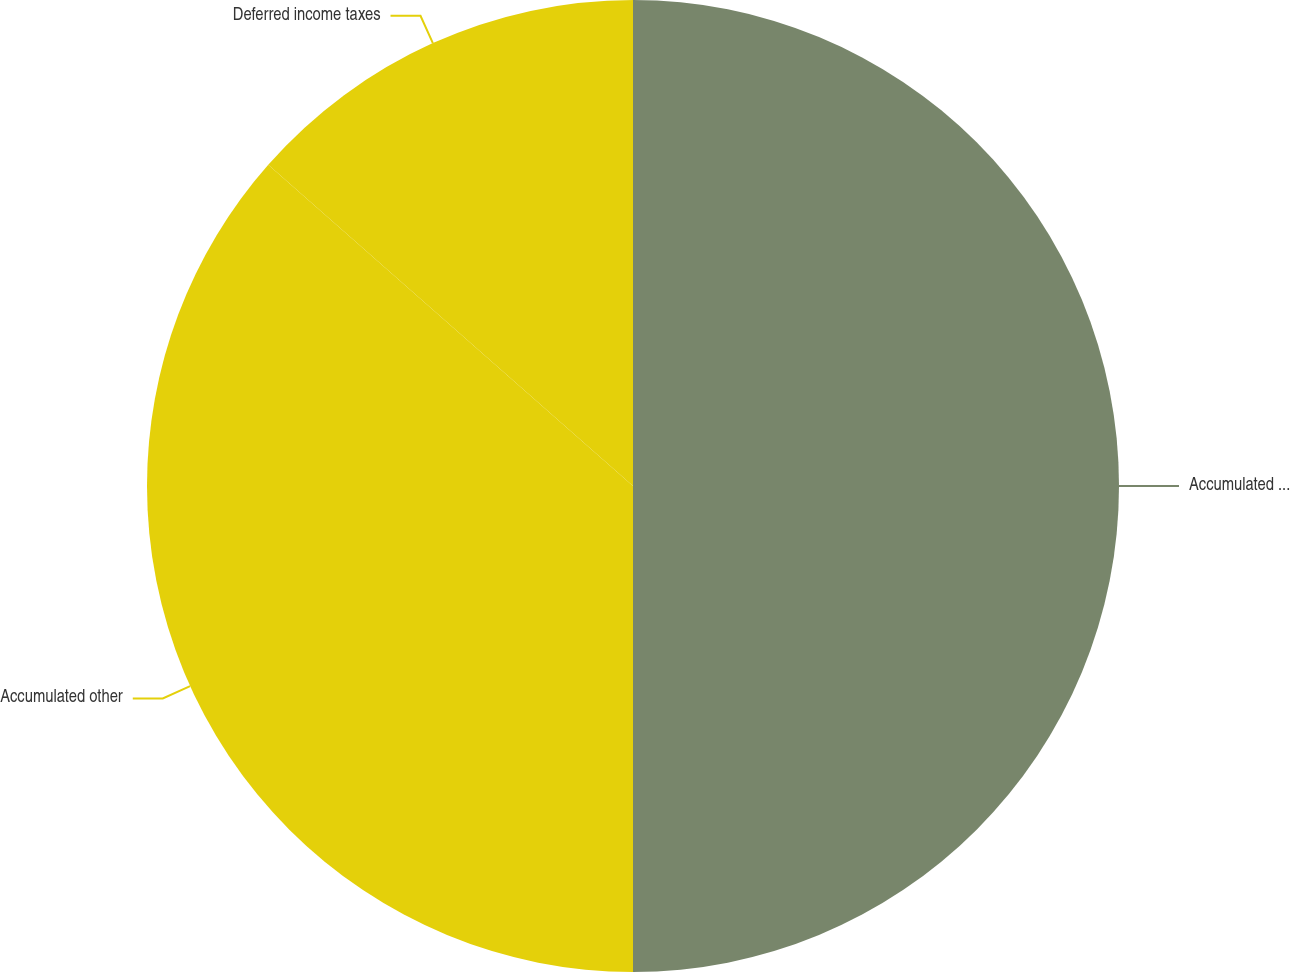<chart> <loc_0><loc_0><loc_500><loc_500><pie_chart><fcel>Accumulated loss<fcel>Accumulated other<fcel>Deferred income taxes<nl><fcel>50.0%<fcel>36.49%<fcel>13.51%<nl></chart> 